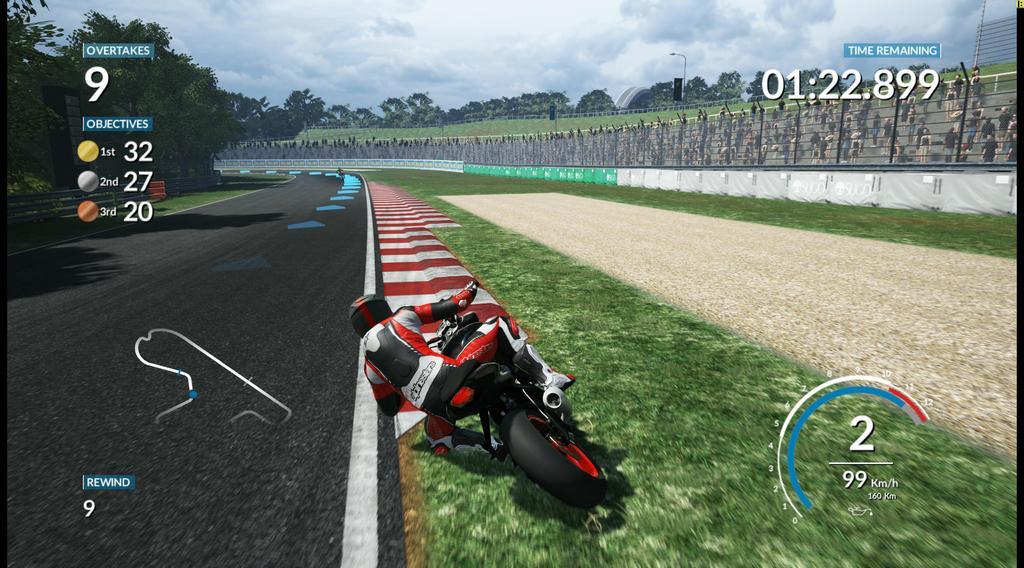Could you give a brief overview of what you see in this image? It is an animated image. In this image we can see a person wearing the helmet and riding the bike. We can also see the road, ground, wall, fence and also many trees. We can also see the light poles, text and also numbers. At the top we can see the sky with the clouds and the image has black color borders on two sides. 